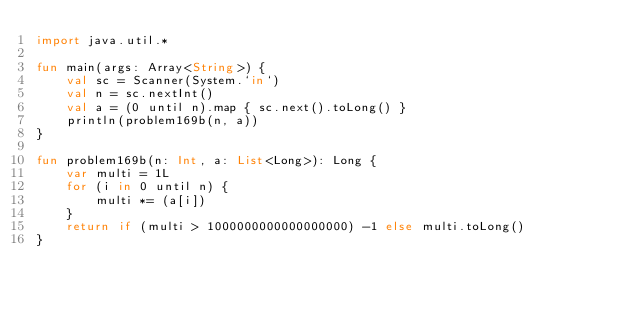<code> <loc_0><loc_0><loc_500><loc_500><_Kotlin_>import java.util.*

fun main(args: Array<String>) {
    val sc = Scanner(System.`in`)
    val n = sc.nextInt()
    val a = (0 until n).map { sc.next().toLong() }
    println(problem169b(n, a))
}

fun problem169b(n: Int, a: List<Long>): Long {
    var multi = 1L
    for (i in 0 until n) {
        multi *= (a[i])
    }
    return if (multi > 1000000000000000000) -1 else multi.toLong()
}</code> 